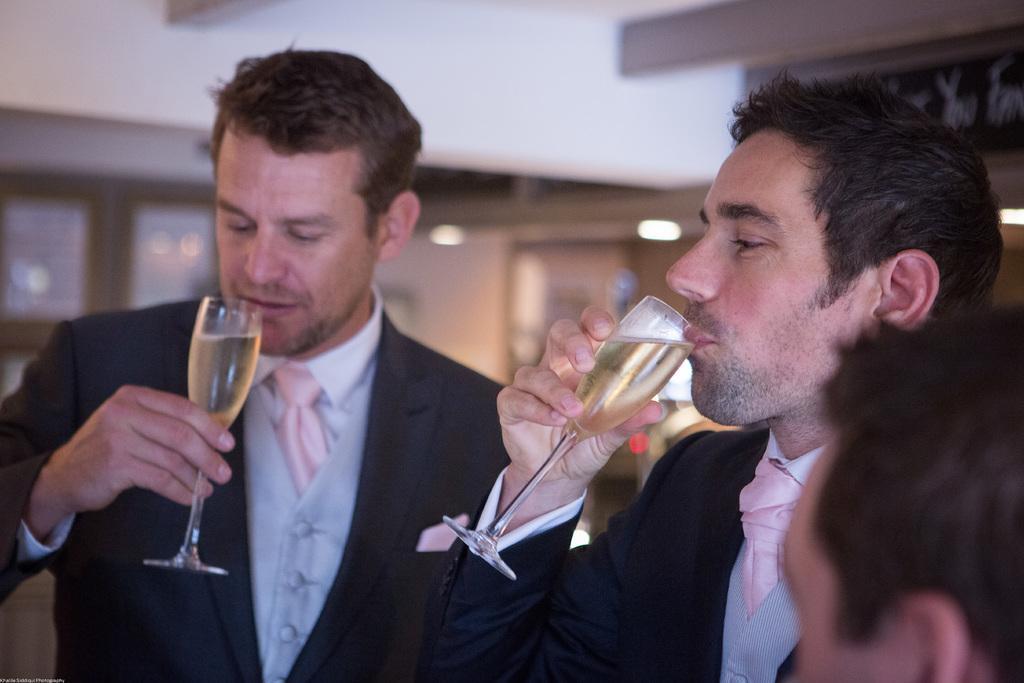Could you give a brief overview of what you see in this image? The two persons standing and drinking a glass of wine and there is other person in the right corner. 